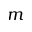<formula> <loc_0><loc_0><loc_500><loc_500>m</formula> 